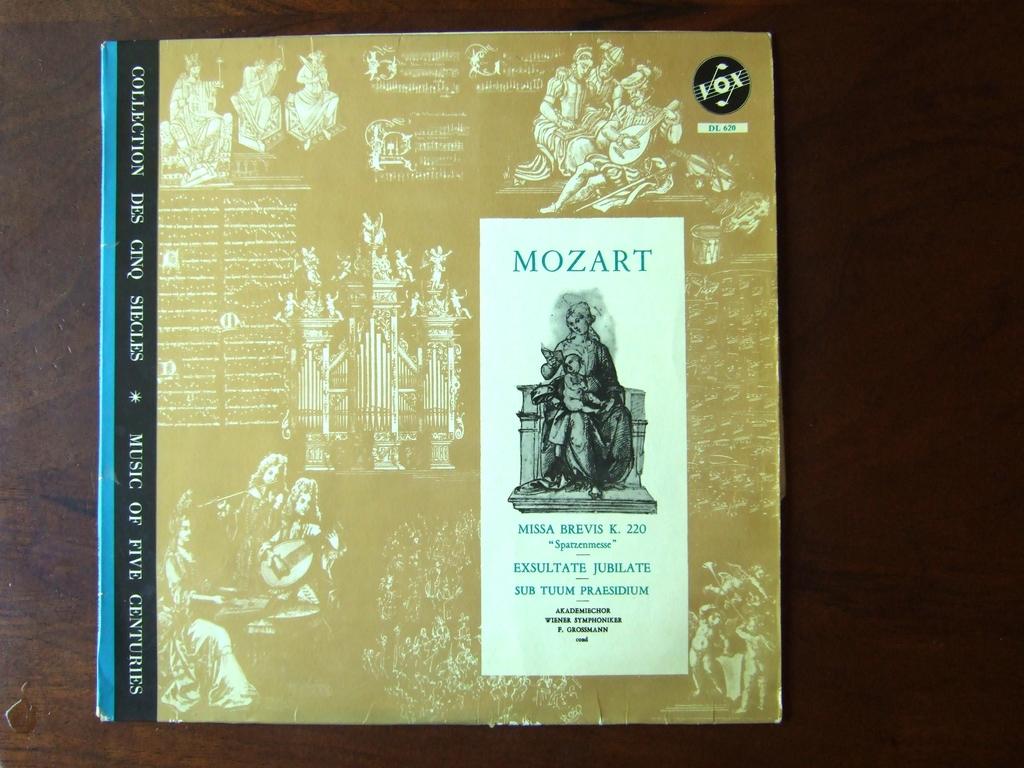Who is the music publisher of this work?
Provide a short and direct response. Mozart. Who wrote this music?
Your answer should be very brief. Mozart. 